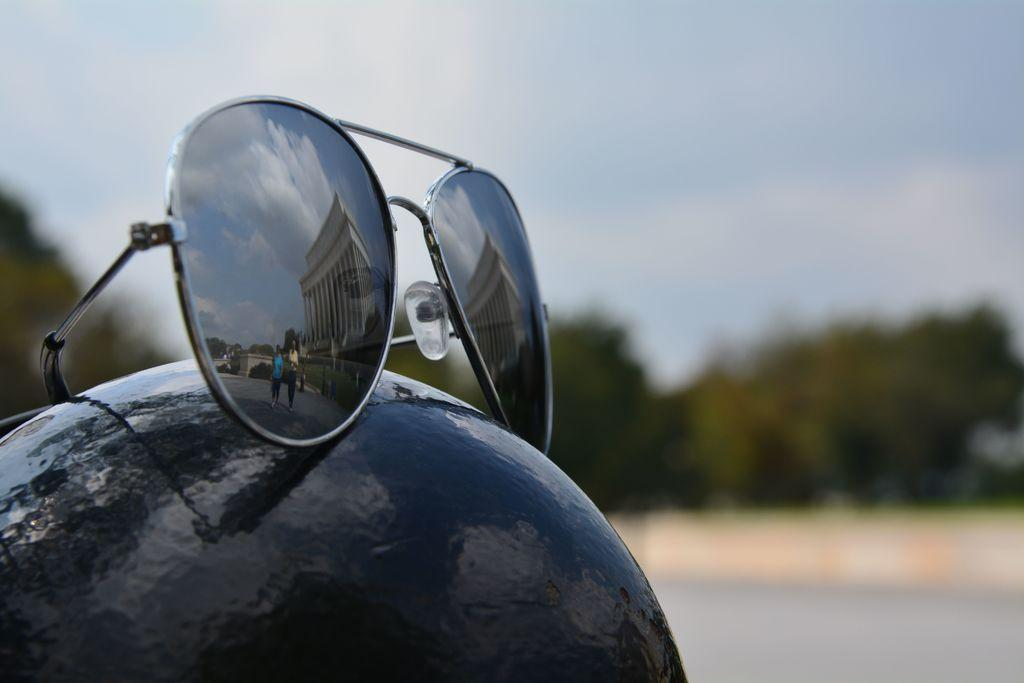What object is placed on the helmet in the image? There are spectacles on a black color helmet in the image. What can be seen on the right side of the image? There is a road on the right side of the image. What type of vegetation is in the middle of the image? There are trees in the middle of the image. What is visible at the top of the image? The sky is visible at the top of the image. Can you tell me how many knives are being held by the donkey in the image? There is no donkey or knife present in the image. Is there a baby visible in the image? There is no baby visible in the image. 